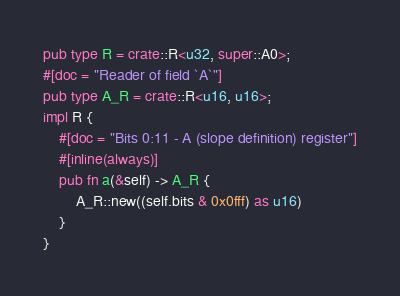<code> <loc_0><loc_0><loc_500><loc_500><_Rust_>pub type R = crate::R<u32, super::A0>;
#[doc = "Reader of field `A`"]
pub type A_R = crate::R<u16, u16>;
impl R {
    #[doc = "Bits 0:11 - A (slope definition) register"]
    #[inline(always)]
    pub fn a(&self) -> A_R {
        A_R::new((self.bits & 0x0fff) as u16)
    }
}
</code> 